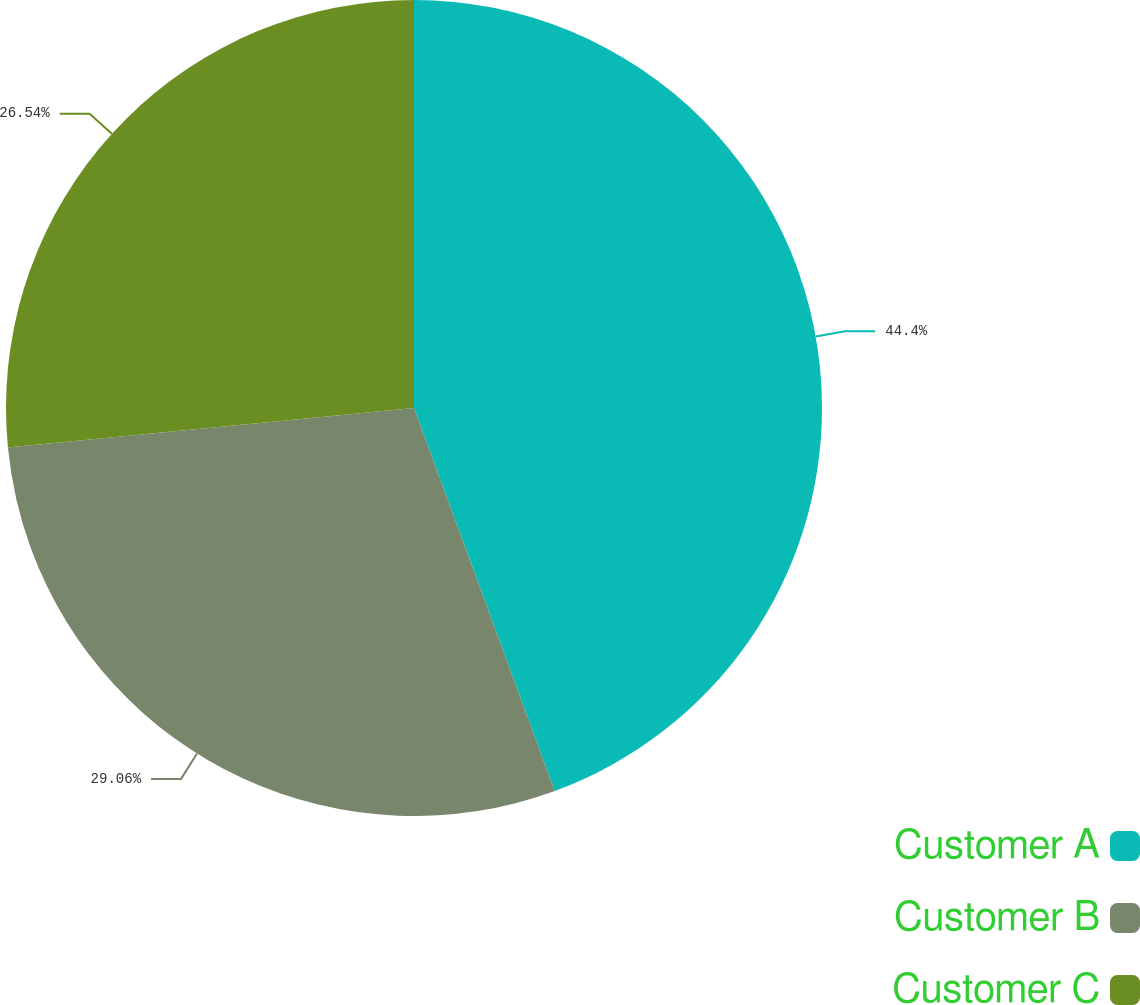Convert chart to OTSL. <chart><loc_0><loc_0><loc_500><loc_500><pie_chart><fcel>Customer A<fcel>Customer B<fcel>Customer C<nl><fcel>44.39%<fcel>29.06%<fcel>26.54%<nl></chart> 